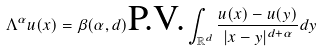Convert formula to latex. <formula><loc_0><loc_0><loc_500><loc_500>\Lambda ^ { \alpha } u ( x ) = \beta ( { \alpha } , d ) \text {P.V.} \int _ { \mathbb { R } ^ { d } } \frac { u ( x ) - u ( y ) } { | x - y | ^ { d + \alpha } } d y</formula> 